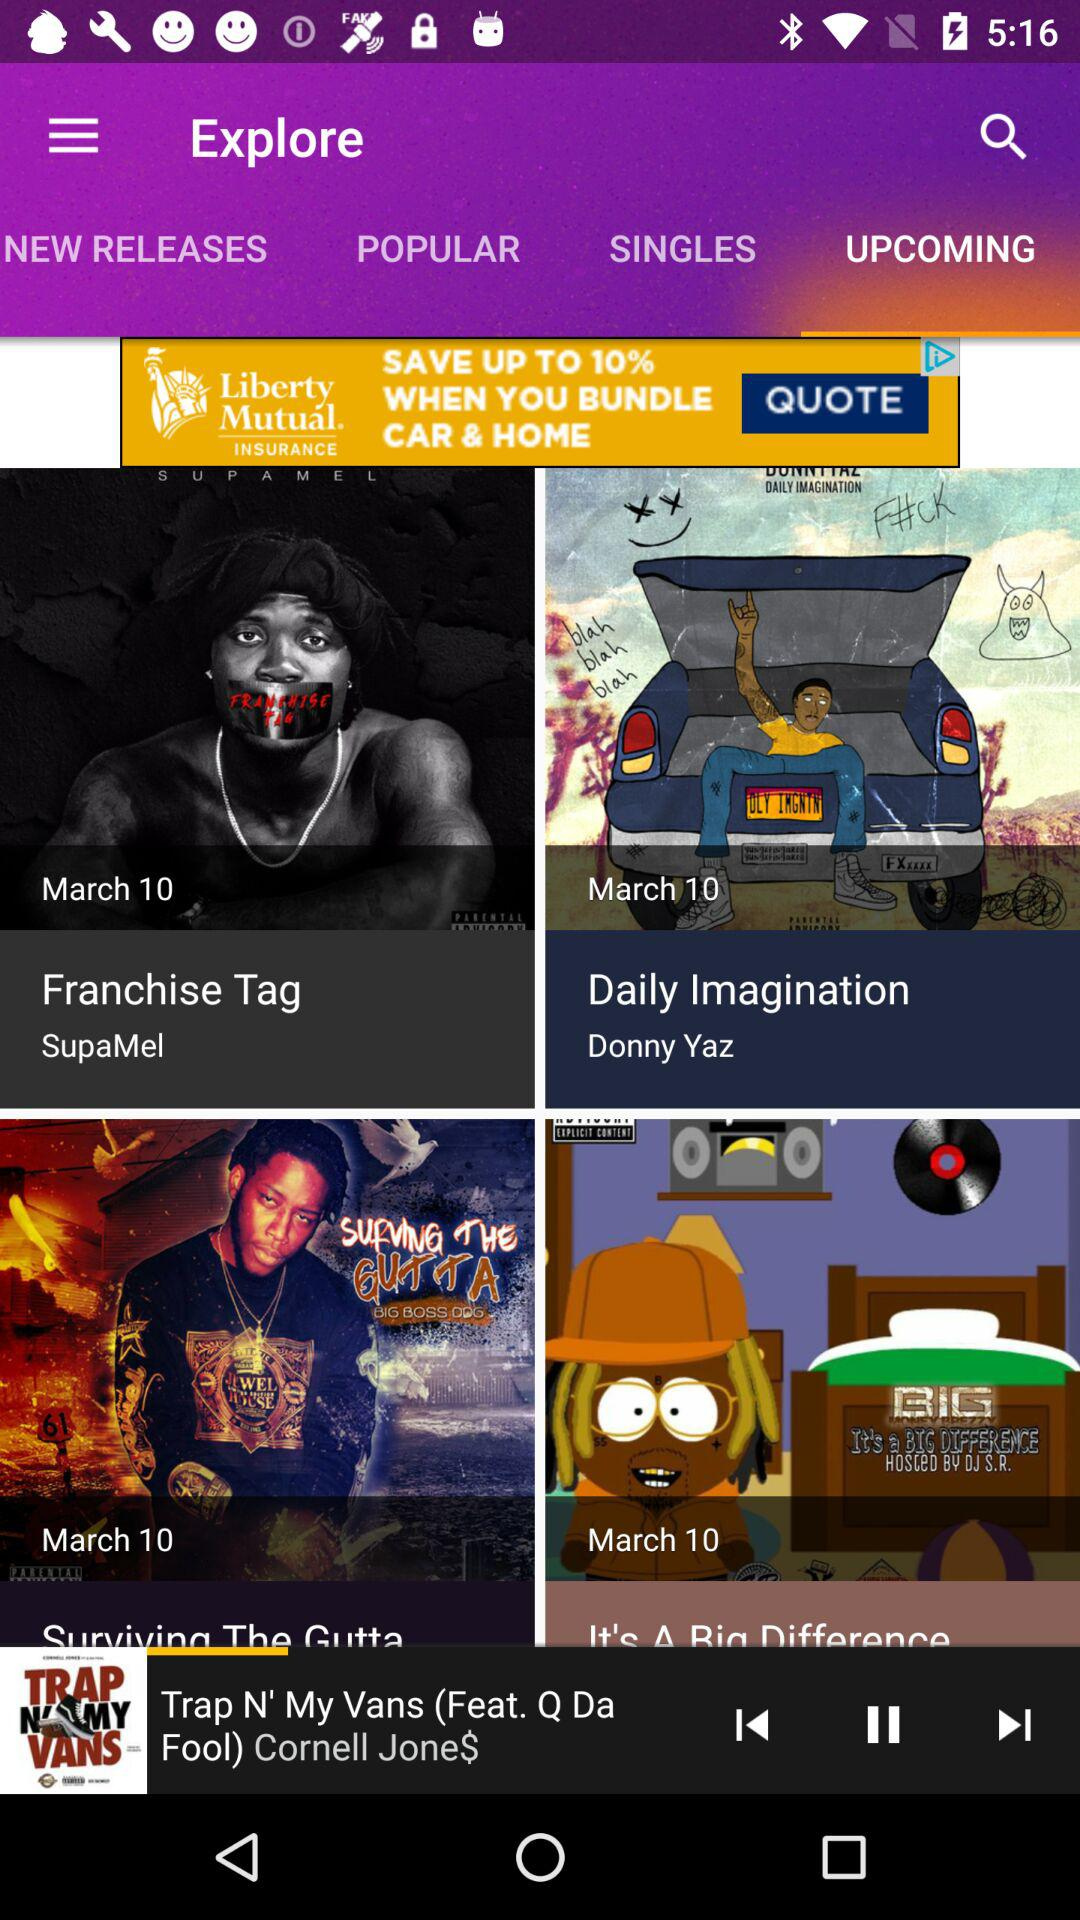Which tab has been selected? The selected tab is upcoming. 